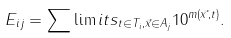<formula> <loc_0><loc_0><loc_500><loc_500>E _ { i j } = \sum \lim i t s _ { t \in T _ { i } , \vec { x } \in A _ { j } } 1 0 ^ { m ( \vec { x } , t ) } .</formula> 